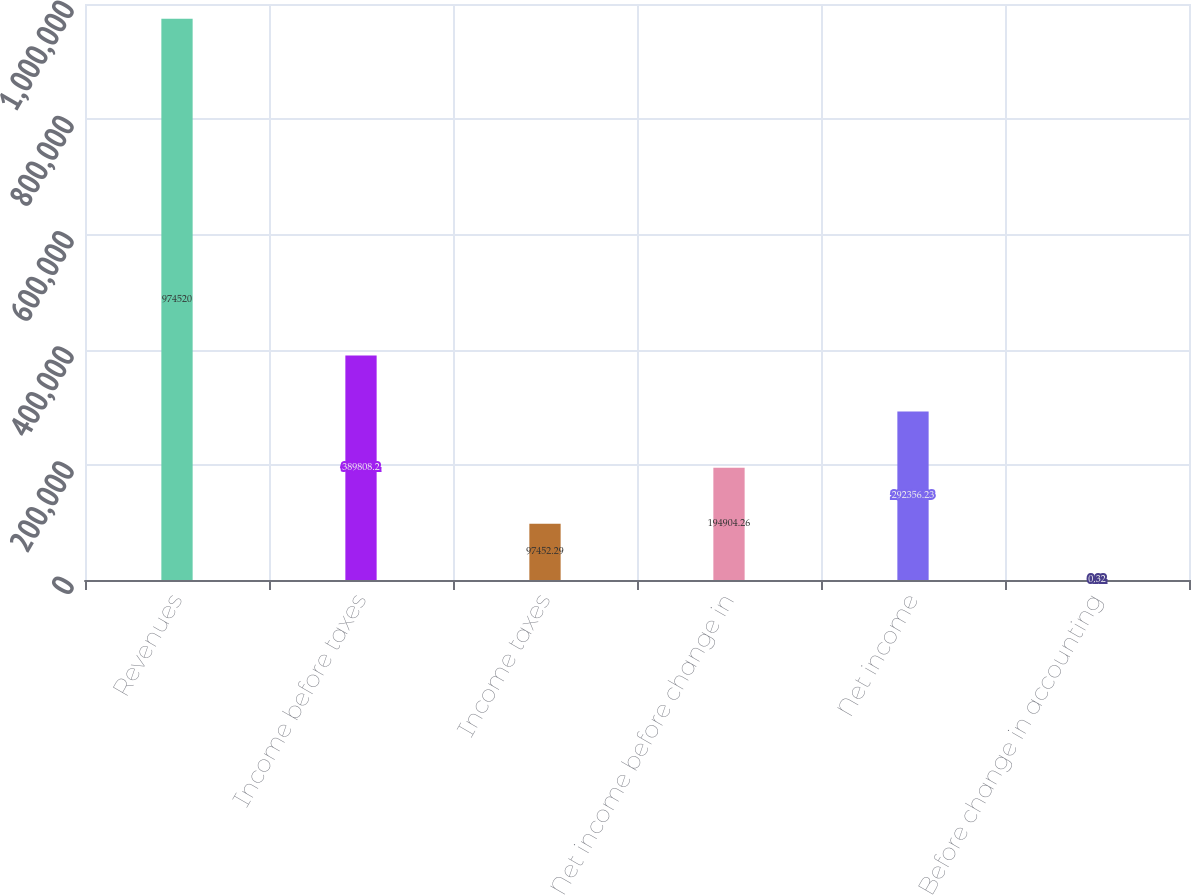<chart> <loc_0><loc_0><loc_500><loc_500><bar_chart><fcel>Revenues<fcel>Income before taxes<fcel>Income taxes<fcel>Net income before change in<fcel>Net income<fcel>Before change in accounting<nl><fcel>974520<fcel>389808<fcel>97452.3<fcel>194904<fcel>292356<fcel>0.32<nl></chart> 